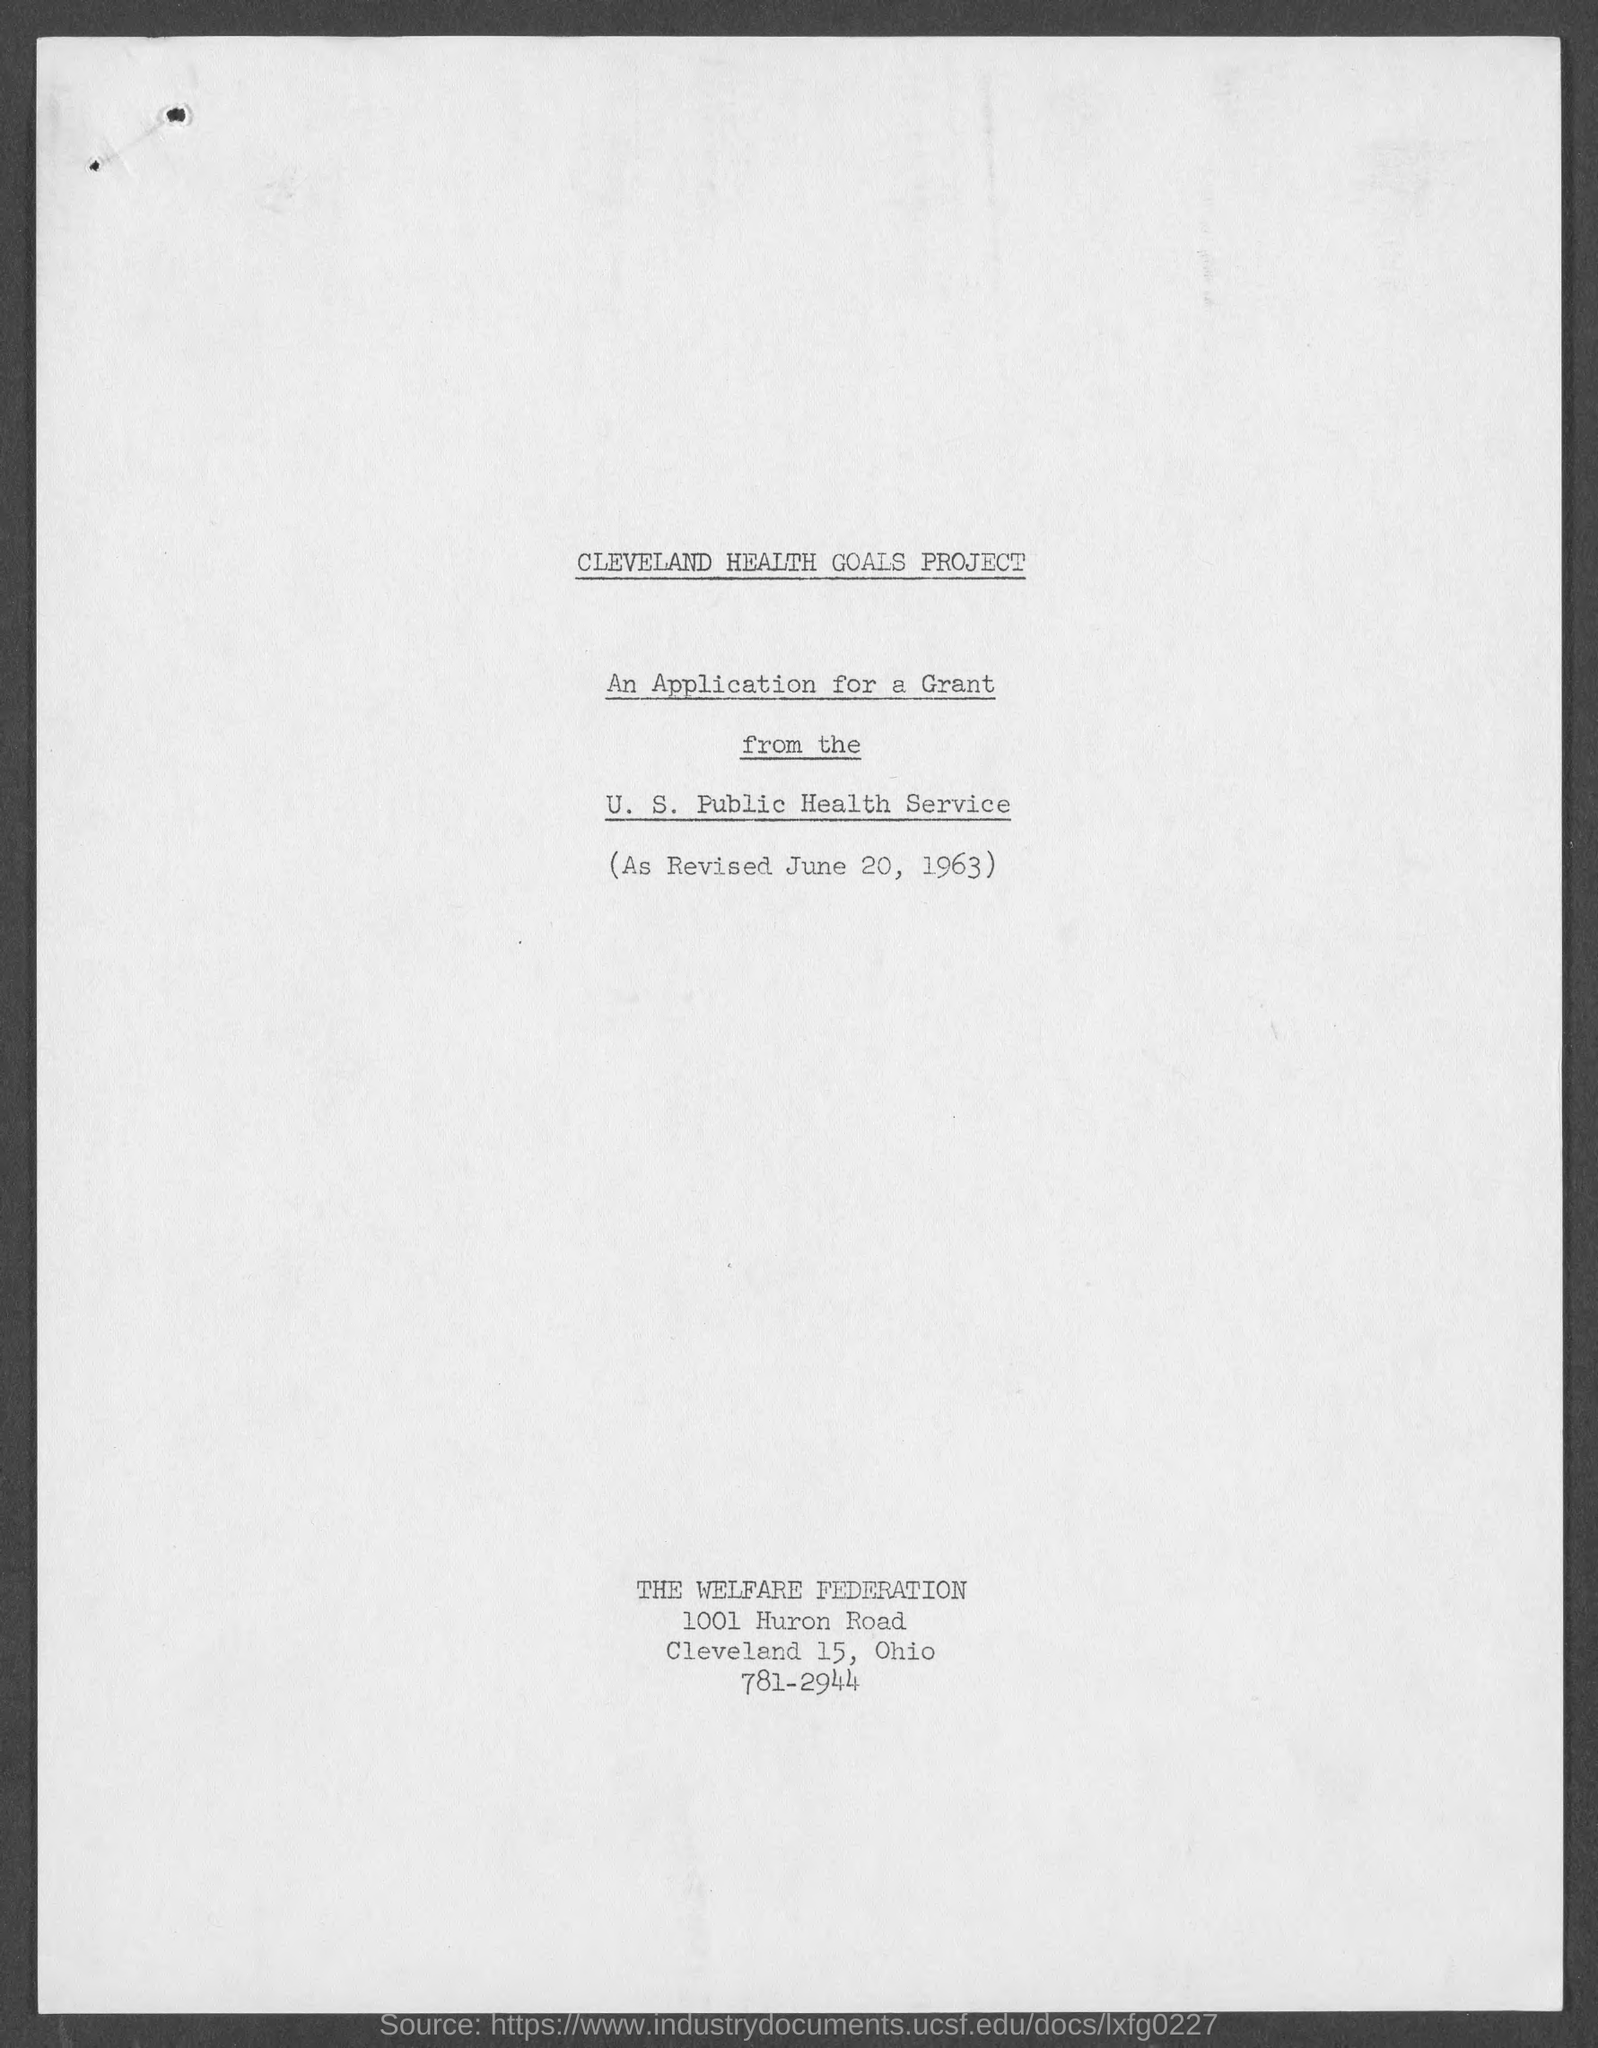When is it revised ?
Offer a terse response. June 20, 1963. 